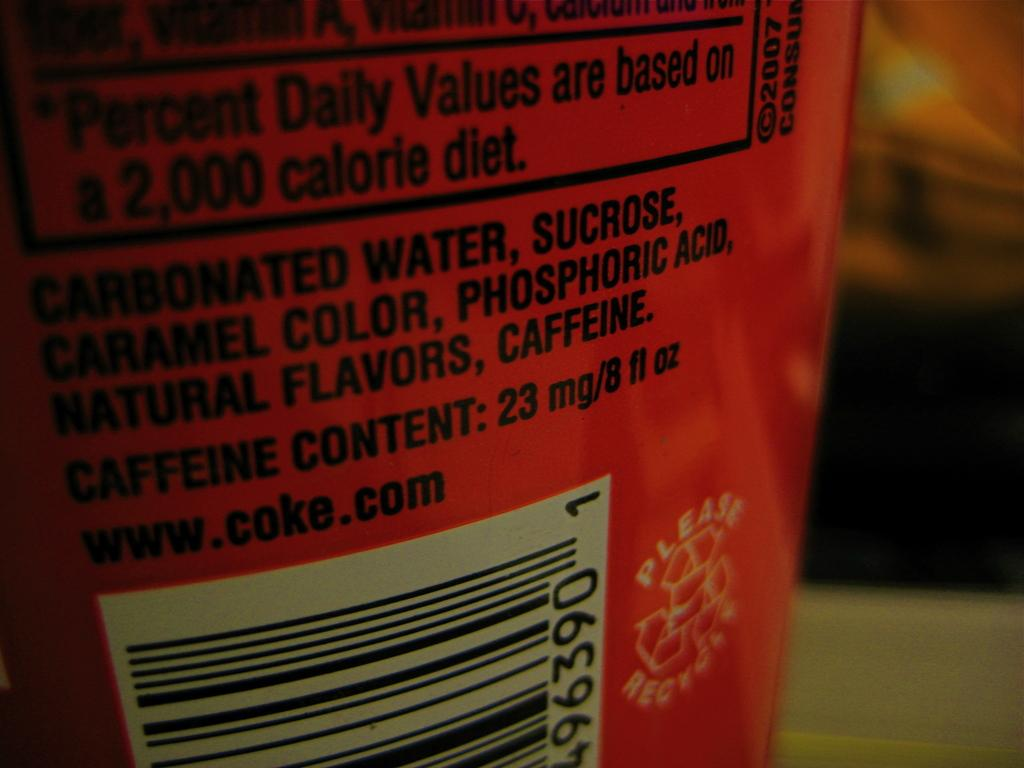<image>
Offer a succinct explanation of the picture presented. Percent Daily Values are based on a 2,000 calorie diet on the back of a coke can with ingredients. 